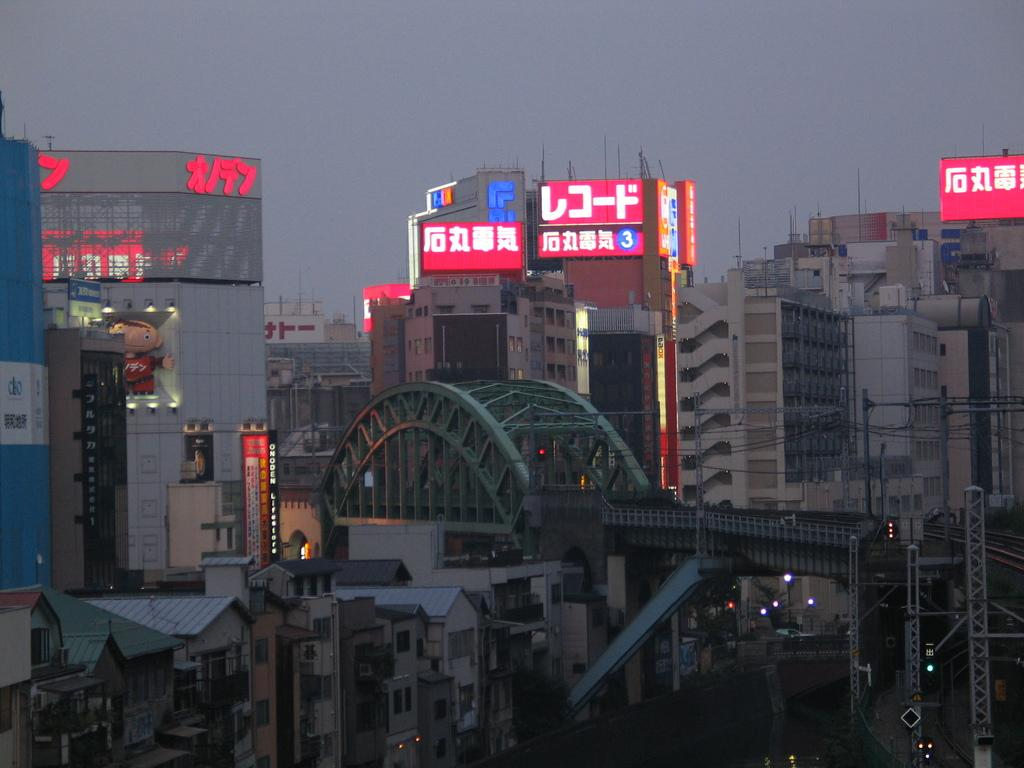What type of structures can be seen in the image? There are buildings in the image. What other objects are present in the image? There are boards, lights, and wires visible in the image. Are there any written words in the image? Yes, there are words written on the boards or other visible surfaces. Can you see your aunt holding a bone in the image? There is no aunt or bone present in the image. What type of observation can be made about the image? The provided facts do not allow for a specific observation to be made about the image. 